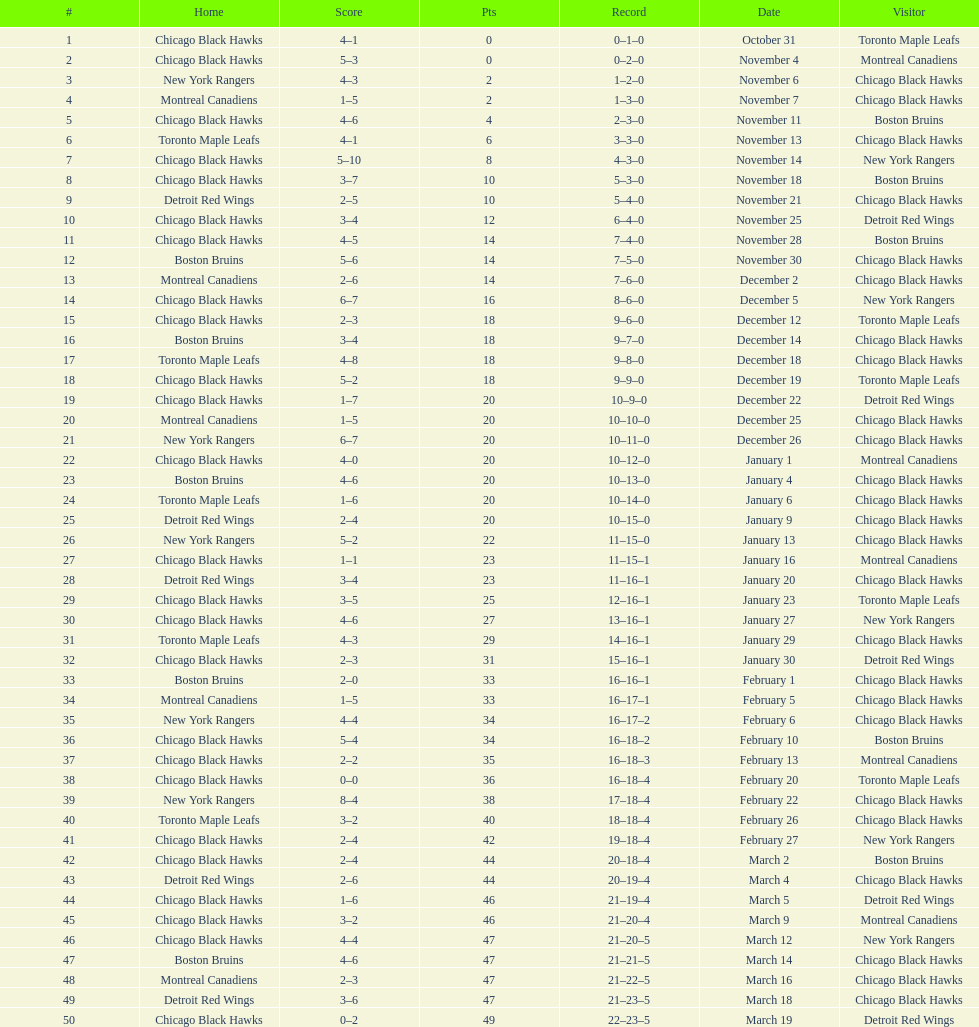How long is the duration of one season (from the first game to the last)? 5 months. 